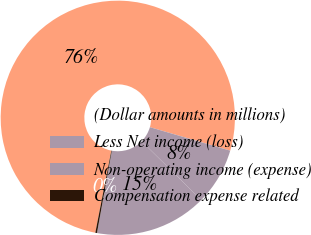Convert chart to OTSL. <chart><loc_0><loc_0><loc_500><loc_500><pie_chart><fcel>(Dollar amounts in millions)<fcel>Less Net income (loss)<fcel>Non-operating income (expense)<fcel>Compensation expense related<nl><fcel>76.45%<fcel>7.85%<fcel>15.47%<fcel>0.23%<nl></chart> 